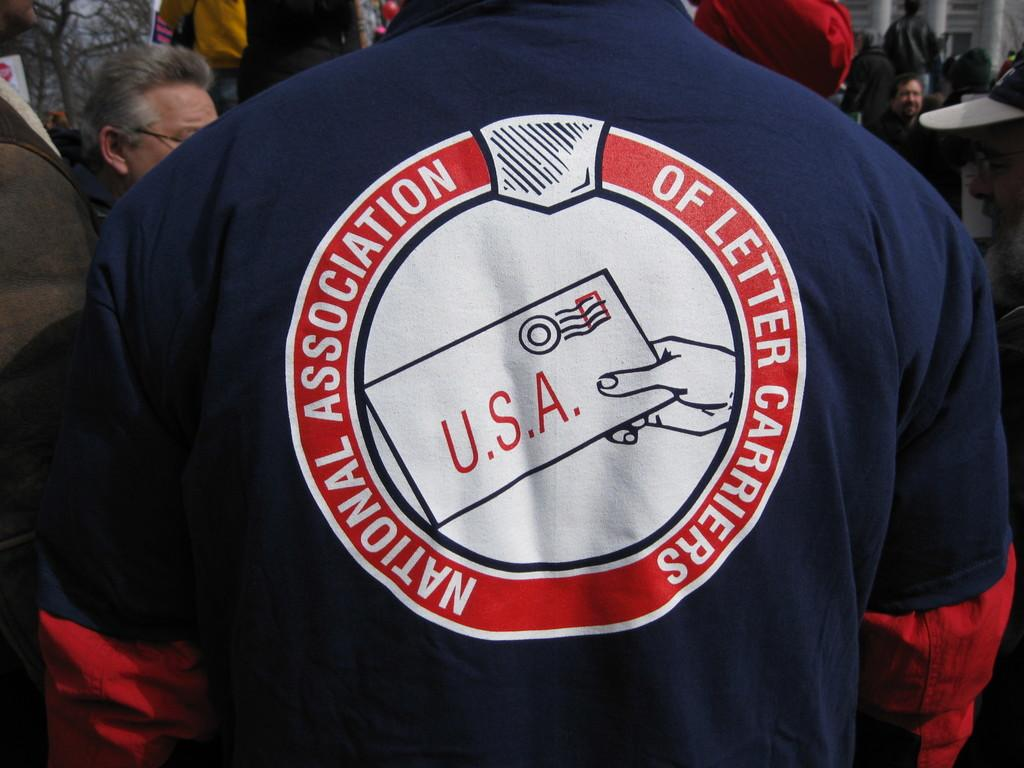<image>
Describe the image concisely. A man has his back to the camera wearing a shirt saying national association of USA letter carriers 